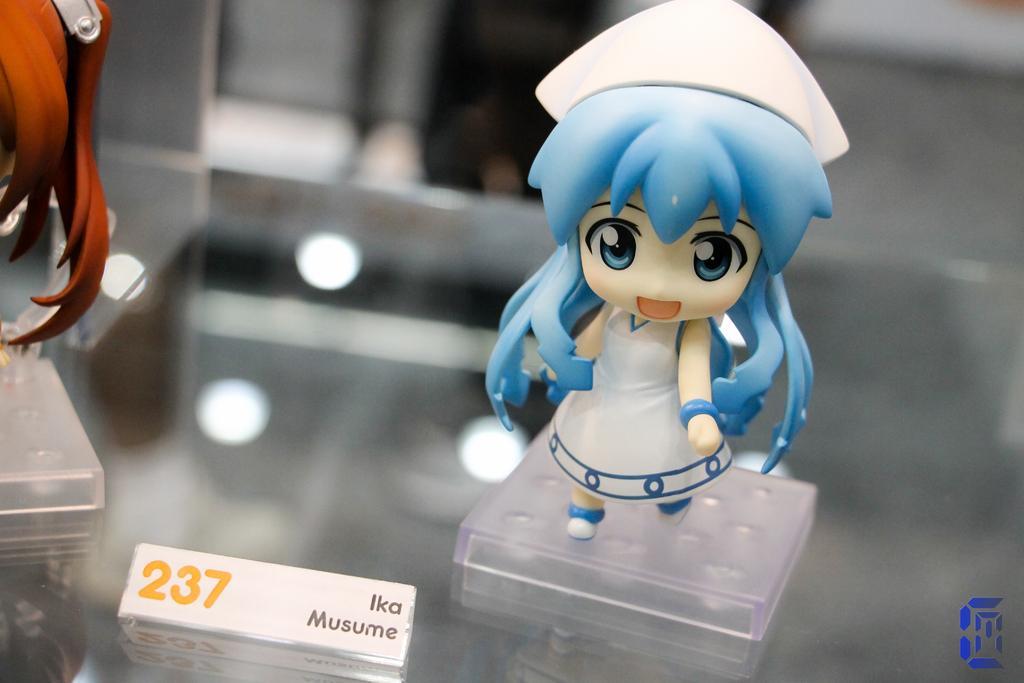In one or two sentences, can you explain what this image depicts? In this image we can see a toy, name board on the glass. 